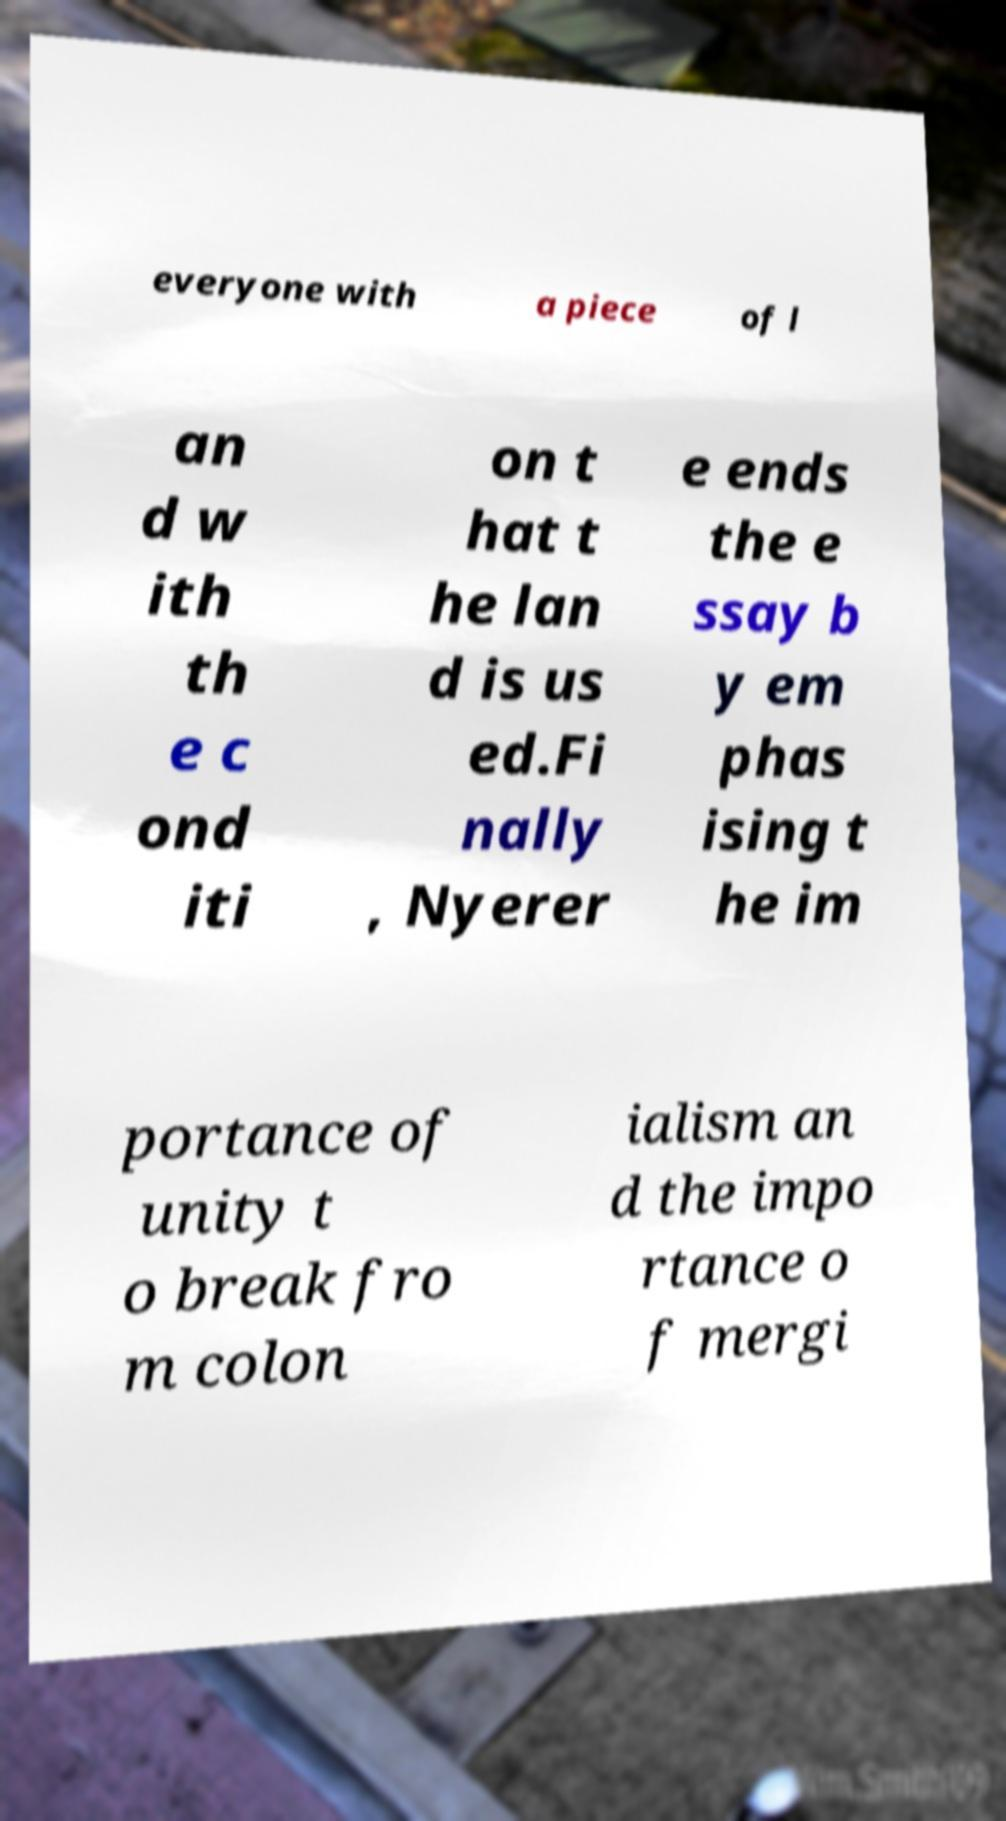I need the written content from this picture converted into text. Can you do that? everyone with a piece of l an d w ith th e c ond iti on t hat t he lan d is us ed.Fi nally , Nyerer e ends the e ssay b y em phas ising t he im portance of unity t o break fro m colon ialism an d the impo rtance o f mergi 